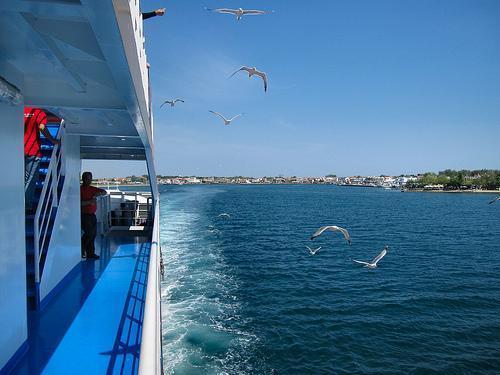How many people can you see?
Give a very brief answer. 3. 